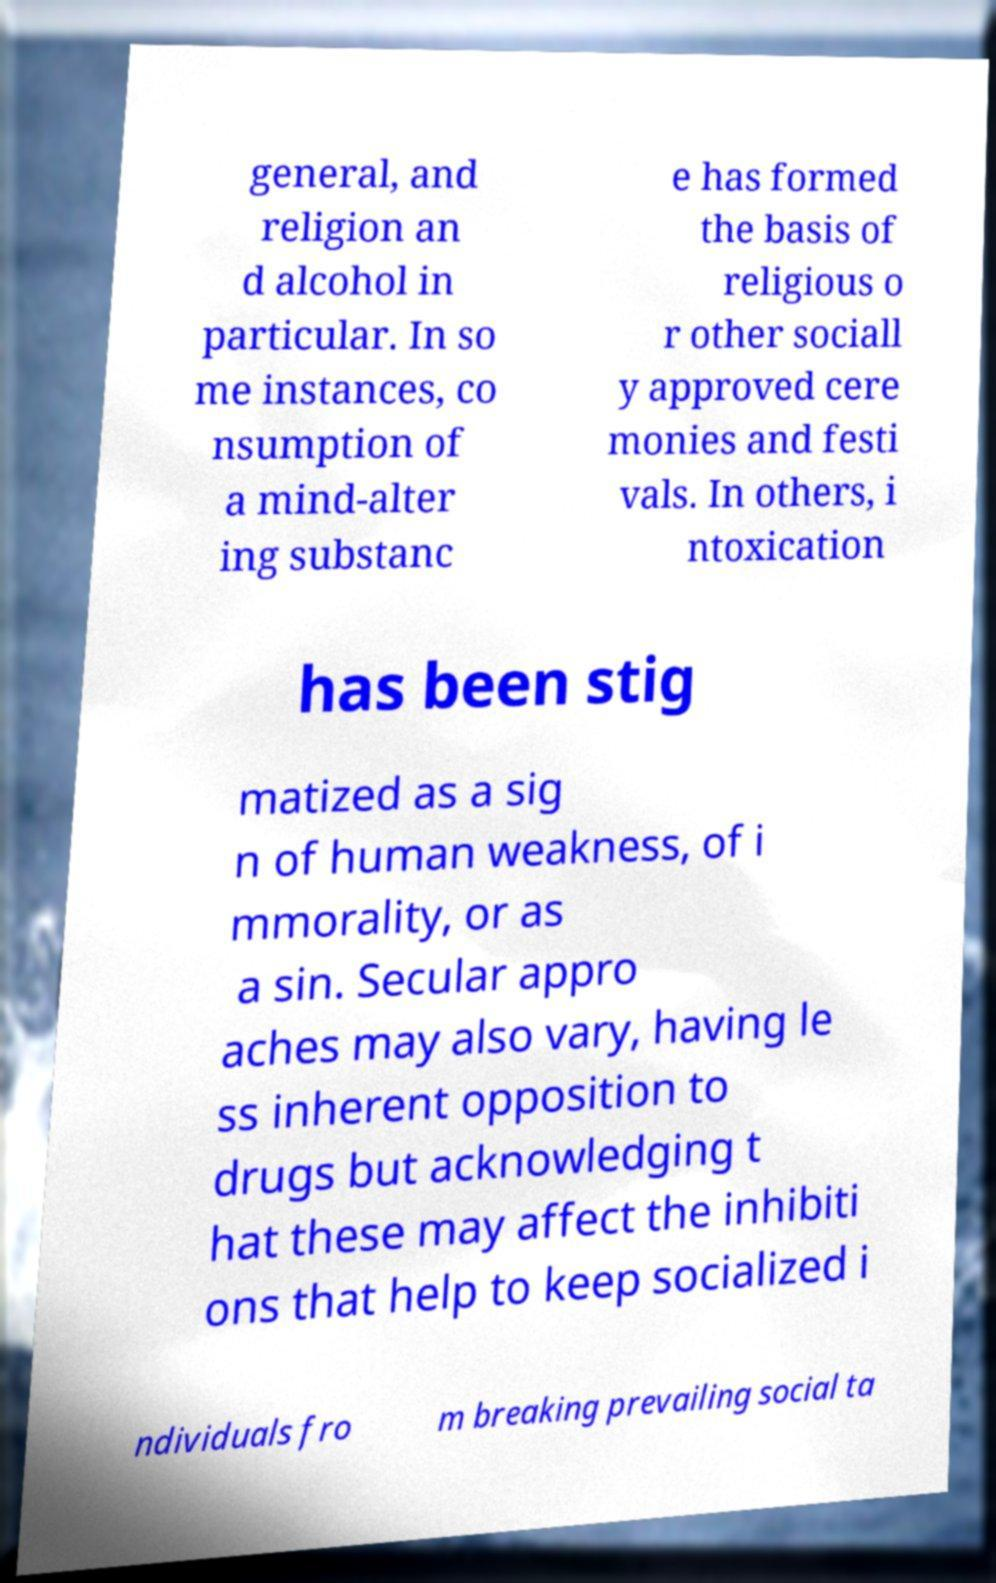There's text embedded in this image that I need extracted. Can you transcribe it verbatim? general, and religion an d alcohol in particular. In so me instances, co nsumption of a mind-alter ing substanc e has formed the basis of religious o r other sociall y approved cere monies and festi vals. In others, i ntoxication has been stig matized as a sig n of human weakness, of i mmorality, or as a sin. Secular appro aches may also vary, having le ss inherent opposition to drugs but acknowledging t hat these may affect the inhibiti ons that help to keep socialized i ndividuals fro m breaking prevailing social ta 